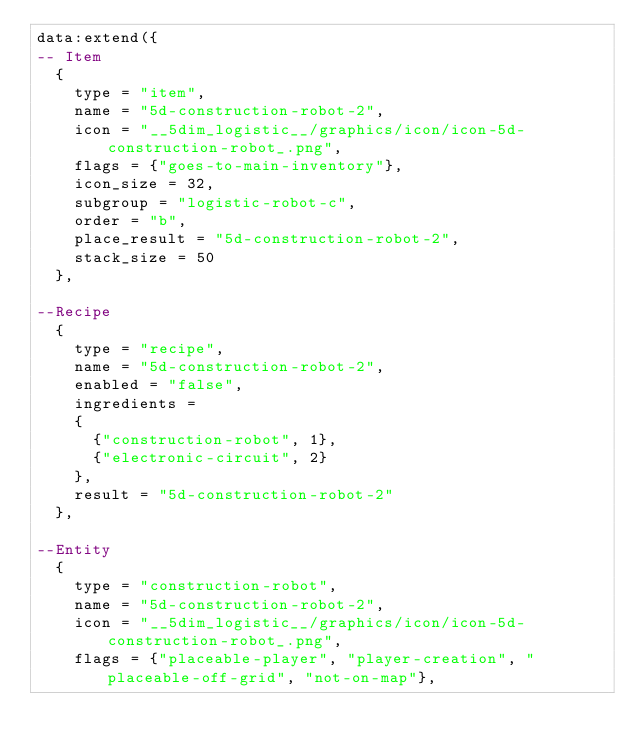Convert code to text. <code><loc_0><loc_0><loc_500><loc_500><_Lua_>data:extend({
-- Item
  {
    type = "item",
    name = "5d-construction-robot-2",
    icon = "__5dim_logistic__/graphics/icon/icon-5d-construction-robot_.png",
    flags = {"goes-to-main-inventory"},
    icon_size = 32,
    subgroup = "logistic-robot-c",
    order = "b",
    place_result = "5d-construction-robot-2",
    stack_size = 50
  },

--Recipe
  {
    type = "recipe",
    name = "5d-construction-robot-2",
    enabled = "false",
    ingredients =
    {
      {"construction-robot", 1},
      {"electronic-circuit", 2}
    },
    result = "5d-construction-robot-2"
  },

--Entity
  {
    type = "construction-robot",
    name = "5d-construction-robot-2",
    icon = "__5dim_logistic__/graphics/icon/icon-5d-construction-robot_.png",
    flags = {"placeable-player", "player-creation", "placeable-off-grid", "not-on-map"},</code> 